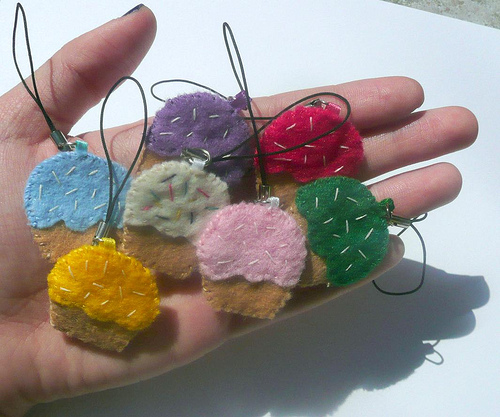<image>
Is there a string under the felt? No. The string is not positioned under the felt. The vertical relationship between these objects is different. Where is the green ornament in relation to the pink ornament? Is it in front of the pink ornament? No. The green ornament is not in front of the pink ornament. The spatial positioning shows a different relationship between these objects. 